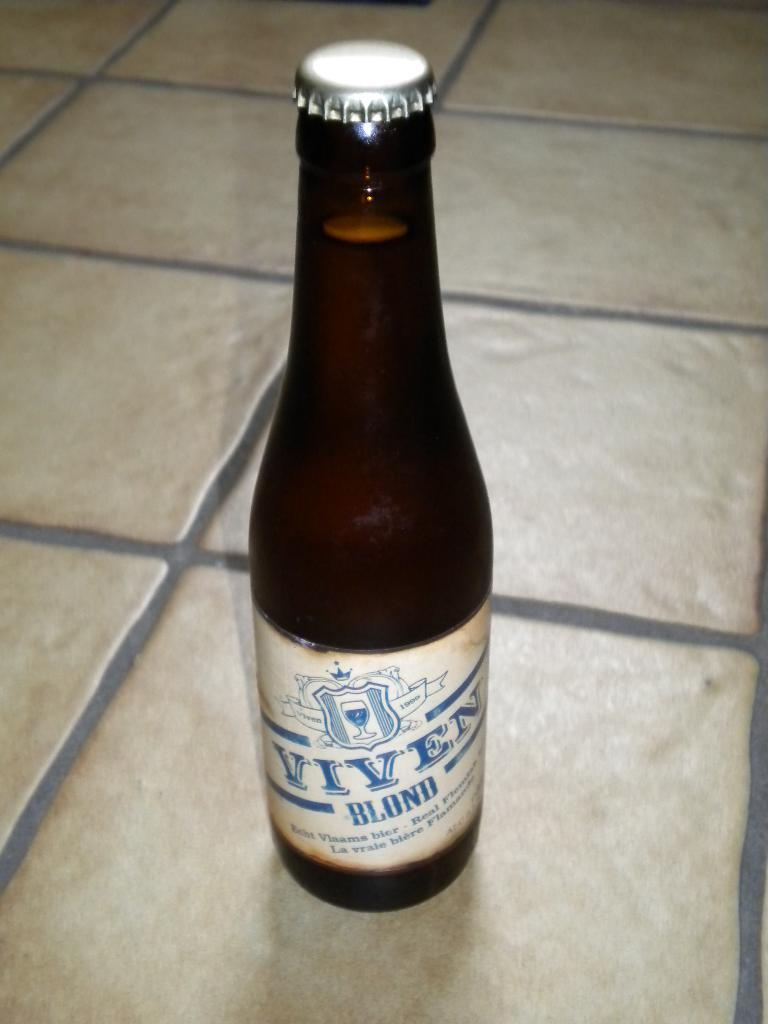<image>
Relay a brief, clear account of the picture shown. A bottle of Viven blond sits on a tile floor. 